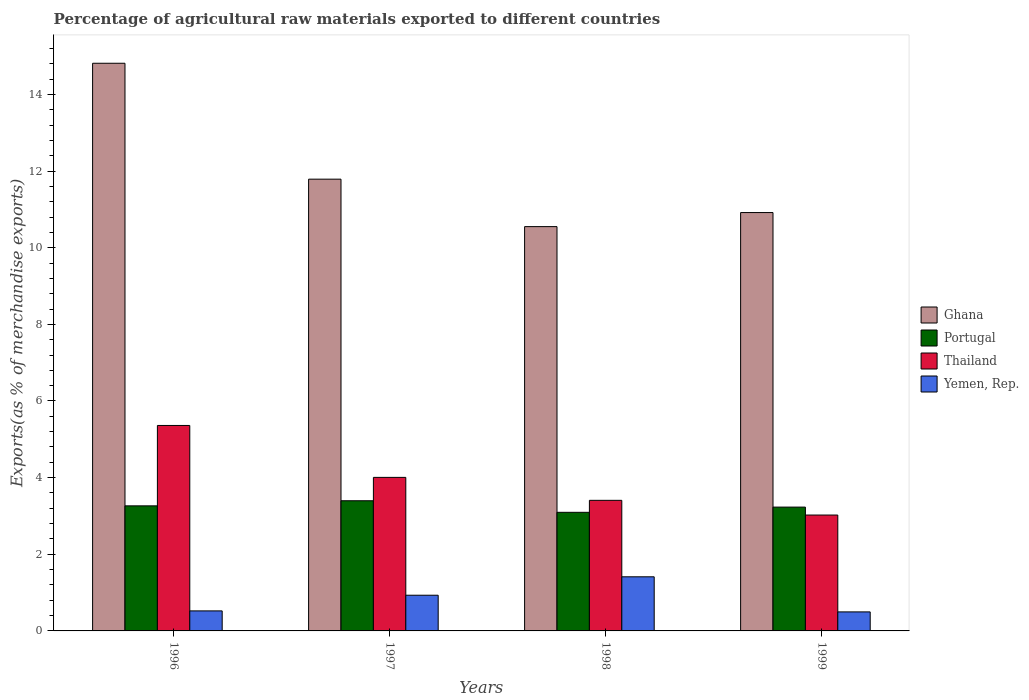How many different coloured bars are there?
Your answer should be compact. 4. How many groups of bars are there?
Make the answer very short. 4. Are the number of bars on each tick of the X-axis equal?
Provide a succinct answer. Yes. How many bars are there on the 1st tick from the left?
Provide a short and direct response. 4. How many bars are there on the 4th tick from the right?
Your answer should be compact. 4. What is the label of the 1st group of bars from the left?
Your response must be concise. 1996. In how many cases, is the number of bars for a given year not equal to the number of legend labels?
Your answer should be very brief. 0. What is the percentage of exports to different countries in Thailand in 1997?
Your response must be concise. 4.01. Across all years, what is the maximum percentage of exports to different countries in Portugal?
Provide a short and direct response. 3.4. Across all years, what is the minimum percentage of exports to different countries in Portugal?
Make the answer very short. 3.09. What is the total percentage of exports to different countries in Ghana in the graph?
Your response must be concise. 48.07. What is the difference between the percentage of exports to different countries in Yemen, Rep. in 1996 and that in 1997?
Offer a very short reply. -0.41. What is the difference between the percentage of exports to different countries in Ghana in 1997 and the percentage of exports to different countries in Thailand in 1998?
Keep it short and to the point. 8.38. What is the average percentage of exports to different countries in Ghana per year?
Your answer should be compact. 12.02. In the year 1999, what is the difference between the percentage of exports to different countries in Portugal and percentage of exports to different countries in Ghana?
Keep it short and to the point. -7.69. In how many years, is the percentage of exports to different countries in Thailand greater than 8 %?
Offer a very short reply. 0. What is the ratio of the percentage of exports to different countries in Ghana in 1996 to that in 1998?
Your answer should be very brief. 1.4. Is the percentage of exports to different countries in Yemen, Rep. in 1998 less than that in 1999?
Ensure brevity in your answer.  No. Is the difference between the percentage of exports to different countries in Portugal in 1996 and 1997 greater than the difference between the percentage of exports to different countries in Ghana in 1996 and 1997?
Make the answer very short. No. What is the difference between the highest and the second highest percentage of exports to different countries in Portugal?
Offer a terse response. 0.13. What is the difference between the highest and the lowest percentage of exports to different countries in Ghana?
Keep it short and to the point. 4.26. What does the 4th bar from the left in 1998 represents?
Offer a terse response. Yemen, Rep. What does the 2nd bar from the right in 1997 represents?
Offer a very short reply. Thailand. Is it the case that in every year, the sum of the percentage of exports to different countries in Thailand and percentage of exports to different countries in Ghana is greater than the percentage of exports to different countries in Portugal?
Provide a short and direct response. Yes. How many bars are there?
Offer a terse response. 16. Are all the bars in the graph horizontal?
Your answer should be compact. No. How many years are there in the graph?
Your answer should be compact. 4. What is the difference between two consecutive major ticks on the Y-axis?
Provide a short and direct response. 2. Does the graph contain any zero values?
Your response must be concise. No. Where does the legend appear in the graph?
Your answer should be very brief. Center right. How many legend labels are there?
Provide a short and direct response. 4. What is the title of the graph?
Your answer should be compact. Percentage of agricultural raw materials exported to different countries. Does "St. Kitts and Nevis" appear as one of the legend labels in the graph?
Your answer should be very brief. No. What is the label or title of the Y-axis?
Your response must be concise. Exports(as % of merchandise exports). What is the Exports(as % of merchandise exports) in Ghana in 1996?
Offer a very short reply. 14.81. What is the Exports(as % of merchandise exports) of Portugal in 1996?
Offer a very short reply. 3.26. What is the Exports(as % of merchandise exports) in Thailand in 1996?
Offer a very short reply. 5.36. What is the Exports(as % of merchandise exports) in Yemen, Rep. in 1996?
Offer a terse response. 0.52. What is the Exports(as % of merchandise exports) of Ghana in 1997?
Your response must be concise. 11.79. What is the Exports(as % of merchandise exports) in Portugal in 1997?
Keep it short and to the point. 3.4. What is the Exports(as % of merchandise exports) in Thailand in 1997?
Provide a short and direct response. 4.01. What is the Exports(as % of merchandise exports) in Yemen, Rep. in 1997?
Ensure brevity in your answer.  0.93. What is the Exports(as % of merchandise exports) in Ghana in 1998?
Give a very brief answer. 10.55. What is the Exports(as % of merchandise exports) in Portugal in 1998?
Your answer should be compact. 3.09. What is the Exports(as % of merchandise exports) of Thailand in 1998?
Keep it short and to the point. 3.41. What is the Exports(as % of merchandise exports) of Yemen, Rep. in 1998?
Your response must be concise. 1.41. What is the Exports(as % of merchandise exports) in Ghana in 1999?
Provide a short and direct response. 10.92. What is the Exports(as % of merchandise exports) in Portugal in 1999?
Offer a terse response. 3.23. What is the Exports(as % of merchandise exports) in Thailand in 1999?
Your response must be concise. 3.02. What is the Exports(as % of merchandise exports) in Yemen, Rep. in 1999?
Keep it short and to the point. 0.5. Across all years, what is the maximum Exports(as % of merchandise exports) of Ghana?
Provide a succinct answer. 14.81. Across all years, what is the maximum Exports(as % of merchandise exports) of Portugal?
Give a very brief answer. 3.4. Across all years, what is the maximum Exports(as % of merchandise exports) of Thailand?
Your answer should be compact. 5.36. Across all years, what is the maximum Exports(as % of merchandise exports) of Yemen, Rep.?
Keep it short and to the point. 1.41. Across all years, what is the minimum Exports(as % of merchandise exports) of Ghana?
Your answer should be very brief. 10.55. Across all years, what is the minimum Exports(as % of merchandise exports) of Portugal?
Ensure brevity in your answer.  3.09. Across all years, what is the minimum Exports(as % of merchandise exports) in Thailand?
Offer a very short reply. 3.02. Across all years, what is the minimum Exports(as % of merchandise exports) in Yemen, Rep.?
Offer a very short reply. 0.5. What is the total Exports(as % of merchandise exports) in Ghana in the graph?
Give a very brief answer. 48.07. What is the total Exports(as % of merchandise exports) in Portugal in the graph?
Ensure brevity in your answer.  12.99. What is the total Exports(as % of merchandise exports) of Thailand in the graph?
Give a very brief answer. 15.8. What is the total Exports(as % of merchandise exports) in Yemen, Rep. in the graph?
Keep it short and to the point. 3.36. What is the difference between the Exports(as % of merchandise exports) of Ghana in 1996 and that in 1997?
Provide a succinct answer. 3.02. What is the difference between the Exports(as % of merchandise exports) of Portugal in 1996 and that in 1997?
Your answer should be very brief. -0.13. What is the difference between the Exports(as % of merchandise exports) in Thailand in 1996 and that in 1997?
Provide a short and direct response. 1.35. What is the difference between the Exports(as % of merchandise exports) in Yemen, Rep. in 1996 and that in 1997?
Give a very brief answer. -0.41. What is the difference between the Exports(as % of merchandise exports) of Ghana in 1996 and that in 1998?
Offer a terse response. 4.26. What is the difference between the Exports(as % of merchandise exports) in Portugal in 1996 and that in 1998?
Offer a very short reply. 0.17. What is the difference between the Exports(as % of merchandise exports) of Thailand in 1996 and that in 1998?
Provide a succinct answer. 1.95. What is the difference between the Exports(as % of merchandise exports) in Yemen, Rep. in 1996 and that in 1998?
Ensure brevity in your answer.  -0.89. What is the difference between the Exports(as % of merchandise exports) of Ghana in 1996 and that in 1999?
Ensure brevity in your answer.  3.9. What is the difference between the Exports(as % of merchandise exports) in Portugal in 1996 and that in 1999?
Your answer should be compact. 0.03. What is the difference between the Exports(as % of merchandise exports) of Thailand in 1996 and that in 1999?
Provide a succinct answer. 2.34. What is the difference between the Exports(as % of merchandise exports) in Yemen, Rep. in 1996 and that in 1999?
Your answer should be compact. 0.03. What is the difference between the Exports(as % of merchandise exports) in Ghana in 1997 and that in 1998?
Make the answer very short. 1.24. What is the difference between the Exports(as % of merchandise exports) of Portugal in 1997 and that in 1998?
Keep it short and to the point. 0.3. What is the difference between the Exports(as % of merchandise exports) in Thailand in 1997 and that in 1998?
Offer a terse response. 0.6. What is the difference between the Exports(as % of merchandise exports) of Yemen, Rep. in 1997 and that in 1998?
Provide a succinct answer. -0.48. What is the difference between the Exports(as % of merchandise exports) in Ghana in 1997 and that in 1999?
Offer a very short reply. 0.87. What is the difference between the Exports(as % of merchandise exports) in Portugal in 1997 and that in 1999?
Your answer should be compact. 0.17. What is the difference between the Exports(as % of merchandise exports) of Thailand in 1997 and that in 1999?
Provide a short and direct response. 0.98. What is the difference between the Exports(as % of merchandise exports) in Yemen, Rep. in 1997 and that in 1999?
Ensure brevity in your answer.  0.44. What is the difference between the Exports(as % of merchandise exports) of Ghana in 1998 and that in 1999?
Your answer should be compact. -0.37. What is the difference between the Exports(as % of merchandise exports) in Portugal in 1998 and that in 1999?
Offer a terse response. -0.14. What is the difference between the Exports(as % of merchandise exports) in Thailand in 1998 and that in 1999?
Make the answer very short. 0.38. What is the difference between the Exports(as % of merchandise exports) in Yemen, Rep. in 1998 and that in 1999?
Provide a short and direct response. 0.92. What is the difference between the Exports(as % of merchandise exports) in Ghana in 1996 and the Exports(as % of merchandise exports) in Portugal in 1997?
Your answer should be very brief. 11.42. What is the difference between the Exports(as % of merchandise exports) in Ghana in 1996 and the Exports(as % of merchandise exports) in Thailand in 1997?
Your answer should be very brief. 10.81. What is the difference between the Exports(as % of merchandise exports) in Ghana in 1996 and the Exports(as % of merchandise exports) in Yemen, Rep. in 1997?
Your response must be concise. 13.88. What is the difference between the Exports(as % of merchandise exports) of Portugal in 1996 and the Exports(as % of merchandise exports) of Thailand in 1997?
Offer a terse response. -0.74. What is the difference between the Exports(as % of merchandise exports) in Portugal in 1996 and the Exports(as % of merchandise exports) in Yemen, Rep. in 1997?
Your response must be concise. 2.33. What is the difference between the Exports(as % of merchandise exports) of Thailand in 1996 and the Exports(as % of merchandise exports) of Yemen, Rep. in 1997?
Make the answer very short. 4.43. What is the difference between the Exports(as % of merchandise exports) in Ghana in 1996 and the Exports(as % of merchandise exports) in Portugal in 1998?
Keep it short and to the point. 11.72. What is the difference between the Exports(as % of merchandise exports) of Ghana in 1996 and the Exports(as % of merchandise exports) of Thailand in 1998?
Give a very brief answer. 11.41. What is the difference between the Exports(as % of merchandise exports) in Ghana in 1996 and the Exports(as % of merchandise exports) in Yemen, Rep. in 1998?
Offer a very short reply. 13.4. What is the difference between the Exports(as % of merchandise exports) in Portugal in 1996 and the Exports(as % of merchandise exports) in Thailand in 1998?
Your answer should be very brief. -0.14. What is the difference between the Exports(as % of merchandise exports) of Portugal in 1996 and the Exports(as % of merchandise exports) of Yemen, Rep. in 1998?
Your answer should be compact. 1.85. What is the difference between the Exports(as % of merchandise exports) in Thailand in 1996 and the Exports(as % of merchandise exports) in Yemen, Rep. in 1998?
Your answer should be very brief. 3.95. What is the difference between the Exports(as % of merchandise exports) of Ghana in 1996 and the Exports(as % of merchandise exports) of Portugal in 1999?
Give a very brief answer. 11.58. What is the difference between the Exports(as % of merchandise exports) of Ghana in 1996 and the Exports(as % of merchandise exports) of Thailand in 1999?
Provide a short and direct response. 11.79. What is the difference between the Exports(as % of merchandise exports) of Ghana in 1996 and the Exports(as % of merchandise exports) of Yemen, Rep. in 1999?
Your response must be concise. 14.32. What is the difference between the Exports(as % of merchandise exports) in Portugal in 1996 and the Exports(as % of merchandise exports) in Thailand in 1999?
Ensure brevity in your answer.  0.24. What is the difference between the Exports(as % of merchandise exports) of Portugal in 1996 and the Exports(as % of merchandise exports) of Yemen, Rep. in 1999?
Provide a short and direct response. 2.77. What is the difference between the Exports(as % of merchandise exports) in Thailand in 1996 and the Exports(as % of merchandise exports) in Yemen, Rep. in 1999?
Your response must be concise. 4.87. What is the difference between the Exports(as % of merchandise exports) of Ghana in 1997 and the Exports(as % of merchandise exports) of Portugal in 1998?
Make the answer very short. 8.69. What is the difference between the Exports(as % of merchandise exports) in Ghana in 1997 and the Exports(as % of merchandise exports) in Thailand in 1998?
Make the answer very short. 8.38. What is the difference between the Exports(as % of merchandise exports) of Ghana in 1997 and the Exports(as % of merchandise exports) of Yemen, Rep. in 1998?
Keep it short and to the point. 10.38. What is the difference between the Exports(as % of merchandise exports) of Portugal in 1997 and the Exports(as % of merchandise exports) of Thailand in 1998?
Ensure brevity in your answer.  -0.01. What is the difference between the Exports(as % of merchandise exports) of Portugal in 1997 and the Exports(as % of merchandise exports) of Yemen, Rep. in 1998?
Provide a short and direct response. 1.98. What is the difference between the Exports(as % of merchandise exports) in Thailand in 1997 and the Exports(as % of merchandise exports) in Yemen, Rep. in 1998?
Offer a very short reply. 2.59. What is the difference between the Exports(as % of merchandise exports) in Ghana in 1997 and the Exports(as % of merchandise exports) in Portugal in 1999?
Give a very brief answer. 8.56. What is the difference between the Exports(as % of merchandise exports) in Ghana in 1997 and the Exports(as % of merchandise exports) in Thailand in 1999?
Give a very brief answer. 8.76. What is the difference between the Exports(as % of merchandise exports) in Ghana in 1997 and the Exports(as % of merchandise exports) in Yemen, Rep. in 1999?
Keep it short and to the point. 11.29. What is the difference between the Exports(as % of merchandise exports) of Portugal in 1997 and the Exports(as % of merchandise exports) of Thailand in 1999?
Offer a very short reply. 0.37. What is the difference between the Exports(as % of merchandise exports) in Portugal in 1997 and the Exports(as % of merchandise exports) in Yemen, Rep. in 1999?
Keep it short and to the point. 2.9. What is the difference between the Exports(as % of merchandise exports) in Thailand in 1997 and the Exports(as % of merchandise exports) in Yemen, Rep. in 1999?
Offer a very short reply. 3.51. What is the difference between the Exports(as % of merchandise exports) of Ghana in 1998 and the Exports(as % of merchandise exports) of Portugal in 1999?
Make the answer very short. 7.32. What is the difference between the Exports(as % of merchandise exports) in Ghana in 1998 and the Exports(as % of merchandise exports) in Thailand in 1999?
Offer a terse response. 7.53. What is the difference between the Exports(as % of merchandise exports) in Ghana in 1998 and the Exports(as % of merchandise exports) in Yemen, Rep. in 1999?
Give a very brief answer. 10.05. What is the difference between the Exports(as % of merchandise exports) of Portugal in 1998 and the Exports(as % of merchandise exports) of Thailand in 1999?
Your answer should be very brief. 0.07. What is the difference between the Exports(as % of merchandise exports) in Portugal in 1998 and the Exports(as % of merchandise exports) in Yemen, Rep. in 1999?
Give a very brief answer. 2.6. What is the difference between the Exports(as % of merchandise exports) of Thailand in 1998 and the Exports(as % of merchandise exports) of Yemen, Rep. in 1999?
Offer a very short reply. 2.91. What is the average Exports(as % of merchandise exports) in Ghana per year?
Make the answer very short. 12.02. What is the average Exports(as % of merchandise exports) of Portugal per year?
Keep it short and to the point. 3.25. What is the average Exports(as % of merchandise exports) of Thailand per year?
Your response must be concise. 3.95. What is the average Exports(as % of merchandise exports) in Yemen, Rep. per year?
Provide a short and direct response. 0.84. In the year 1996, what is the difference between the Exports(as % of merchandise exports) of Ghana and Exports(as % of merchandise exports) of Portugal?
Make the answer very short. 11.55. In the year 1996, what is the difference between the Exports(as % of merchandise exports) of Ghana and Exports(as % of merchandise exports) of Thailand?
Give a very brief answer. 9.45. In the year 1996, what is the difference between the Exports(as % of merchandise exports) in Ghana and Exports(as % of merchandise exports) in Yemen, Rep.?
Your answer should be compact. 14.29. In the year 1996, what is the difference between the Exports(as % of merchandise exports) in Portugal and Exports(as % of merchandise exports) in Thailand?
Offer a very short reply. -2.1. In the year 1996, what is the difference between the Exports(as % of merchandise exports) in Portugal and Exports(as % of merchandise exports) in Yemen, Rep.?
Provide a short and direct response. 2.74. In the year 1996, what is the difference between the Exports(as % of merchandise exports) in Thailand and Exports(as % of merchandise exports) in Yemen, Rep.?
Keep it short and to the point. 4.84. In the year 1997, what is the difference between the Exports(as % of merchandise exports) of Ghana and Exports(as % of merchandise exports) of Portugal?
Provide a short and direct response. 8.39. In the year 1997, what is the difference between the Exports(as % of merchandise exports) of Ghana and Exports(as % of merchandise exports) of Thailand?
Your response must be concise. 7.78. In the year 1997, what is the difference between the Exports(as % of merchandise exports) of Ghana and Exports(as % of merchandise exports) of Yemen, Rep.?
Provide a succinct answer. 10.86. In the year 1997, what is the difference between the Exports(as % of merchandise exports) in Portugal and Exports(as % of merchandise exports) in Thailand?
Make the answer very short. -0.61. In the year 1997, what is the difference between the Exports(as % of merchandise exports) in Portugal and Exports(as % of merchandise exports) in Yemen, Rep.?
Your answer should be compact. 2.47. In the year 1997, what is the difference between the Exports(as % of merchandise exports) of Thailand and Exports(as % of merchandise exports) of Yemen, Rep.?
Offer a very short reply. 3.08. In the year 1998, what is the difference between the Exports(as % of merchandise exports) in Ghana and Exports(as % of merchandise exports) in Portugal?
Ensure brevity in your answer.  7.46. In the year 1998, what is the difference between the Exports(as % of merchandise exports) of Ghana and Exports(as % of merchandise exports) of Thailand?
Provide a succinct answer. 7.14. In the year 1998, what is the difference between the Exports(as % of merchandise exports) of Ghana and Exports(as % of merchandise exports) of Yemen, Rep.?
Your answer should be very brief. 9.14. In the year 1998, what is the difference between the Exports(as % of merchandise exports) in Portugal and Exports(as % of merchandise exports) in Thailand?
Give a very brief answer. -0.31. In the year 1998, what is the difference between the Exports(as % of merchandise exports) of Portugal and Exports(as % of merchandise exports) of Yemen, Rep.?
Give a very brief answer. 1.68. In the year 1998, what is the difference between the Exports(as % of merchandise exports) in Thailand and Exports(as % of merchandise exports) in Yemen, Rep.?
Your answer should be very brief. 2. In the year 1999, what is the difference between the Exports(as % of merchandise exports) in Ghana and Exports(as % of merchandise exports) in Portugal?
Your response must be concise. 7.69. In the year 1999, what is the difference between the Exports(as % of merchandise exports) of Ghana and Exports(as % of merchandise exports) of Thailand?
Your response must be concise. 7.89. In the year 1999, what is the difference between the Exports(as % of merchandise exports) in Ghana and Exports(as % of merchandise exports) in Yemen, Rep.?
Make the answer very short. 10.42. In the year 1999, what is the difference between the Exports(as % of merchandise exports) in Portugal and Exports(as % of merchandise exports) in Thailand?
Make the answer very short. 0.21. In the year 1999, what is the difference between the Exports(as % of merchandise exports) of Portugal and Exports(as % of merchandise exports) of Yemen, Rep.?
Provide a short and direct response. 2.73. In the year 1999, what is the difference between the Exports(as % of merchandise exports) of Thailand and Exports(as % of merchandise exports) of Yemen, Rep.?
Offer a very short reply. 2.53. What is the ratio of the Exports(as % of merchandise exports) of Ghana in 1996 to that in 1997?
Offer a terse response. 1.26. What is the ratio of the Exports(as % of merchandise exports) in Portugal in 1996 to that in 1997?
Offer a very short reply. 0.96. What is the ratio of the Exports(as % of merchandise exports) in Thailand in 1996 to that in 1997?
Give a very brief answer. 1.34. What is the ratio of the Exports(as % of merchandise exports) in Yemen, Rep. in 1996 to that in 1997?
Make the answer very short. 0.56. What is the ratio of the Exports(as % of merchandise exports) in Ghana in 1996 to that in 1998?
Provide a succinct answer. 1.4. What is the ratio of the Exports(as % of merchandise exports) of Portugal in 1996 to that in 1998?
Offer a very short reply. 1.05. What is the ratio of the Exports(as % of merchandise exports) of Thailand in 1996 to that in 1998?
Your answer should be very brief. 1.57. What is the ratio of the Exports(as % of merchandise exports) in Yemen, Rep. in 1996 to that in 1998?
Offer a very short reply. 0.37. What is the ratio of the Exports(as % of merchandise exports) of Ghana in 1996 to that in 1999?
Ensure brevity in your answer.  1.36. What is the ratio of the Exports(as % of merchandise exports) of Portugal in 1996 to that in 1999?
Offer a very short reply. 1.01. What is the ratio of the Exports(as % of merchandise exports) of Thailand in 1996 to that in 1999?
Your answer should be compact. 1.77. What is the ratio of the Exports(as % of merchandise exports) of Yemen, Rep. in 1996 to that in 1999?
Provide a short and direct response. 1.05. What is the ratio of the Exports(as % of merchandise exports) in Ghana in 1997 to that in 1998?
Ensure brevity in your answer.  1.12. What is the ratio of the Exports(as % of merchandise exports) of Portugal in 1997 to that in 1998?
Offer a very short reply. 1.1. What is the ratio of the Exports(as % of merchandise exports) in Thailand in 1997 to that in 1998?
Your answer should be very brief. 1.18. What is the ratio of the Exports(as % of merchandise exports) of Yemen, Rep. in 1997 to that in 1998?
Provide a short and direct response. 0.66. What is the ratio of the Exports(as % of merchandise exports) in Ghana in 1997 to that in 1999?
Make the answer very short. 1.08. What is the ratio of the Exports(as % of merchandise exports) in Portugal in 1997 to that in 1999?
Your answer should be compact. 1.05. What is the ratio of the Exports(as % of merchandise exports) in Thailand in 1997 to that in 1999?
Your response must be concise. 1.32. What is the ratio of the Exports(as % of merchandise exports) of Yemen, Rep. in 1997 to that in 1999?
Offer a terse response. 1.88. What is the ratio of the Exports(as % of merchandise exports) in Ghana in 1998 to that in 1999?
Your answer should be very brief. 0.97. What is the ratio of the Exports(as % of merchandise exports) in Portugal in 1998 to that in 1999?
Your answer should be very brief. 0.96. What is the ratio of the Exports(as % of merchandise exports) in Thailand in 1998 to that in 1999?
Ensure brevity in your answer.  1.13. What is the ratio of the Exports(as % of merchandise exports) in Yemen, Rep. in 1998 to that in 1999?
Provide a succinct answer. 2.85. What is the difference between the highest and the second highest Exports(as % of merchandise exports) in Ghana?
Your answer should be compact. 3.02. What is the difference between the highest and the second highest Exports(as % of merchandise exports) in Portugal?
Give a very brief answer. 0.13. What is the difference between the highest and the second highest Exports(as % of merchandise exports) of Thailand?
Provide a short and direct response. 1.35. What is the difference between the highest and the second highest Exports(as % of merchandise exports) in Yemen, Rep.?
Give a very brief answer. 0.48. What is the difference between the highest and the lowest Exports(as % of merchandise exports) of Ghana?
Offer a terse response. 4.26. What is the difference between the highest and the lowest Exports(as % of merchandise exports) in Portugal?
Give a very brief answer. 0.3. What is the difference between the highest and the lowest Exports(as % of merchandise exports) of Thailand?
Make the answer very short. 2.34. What is the difference between the highest and the lowest Exports(as % of merchandise exports) of Yemen, Rep.?
Your answer should be very brief. 0.92. 